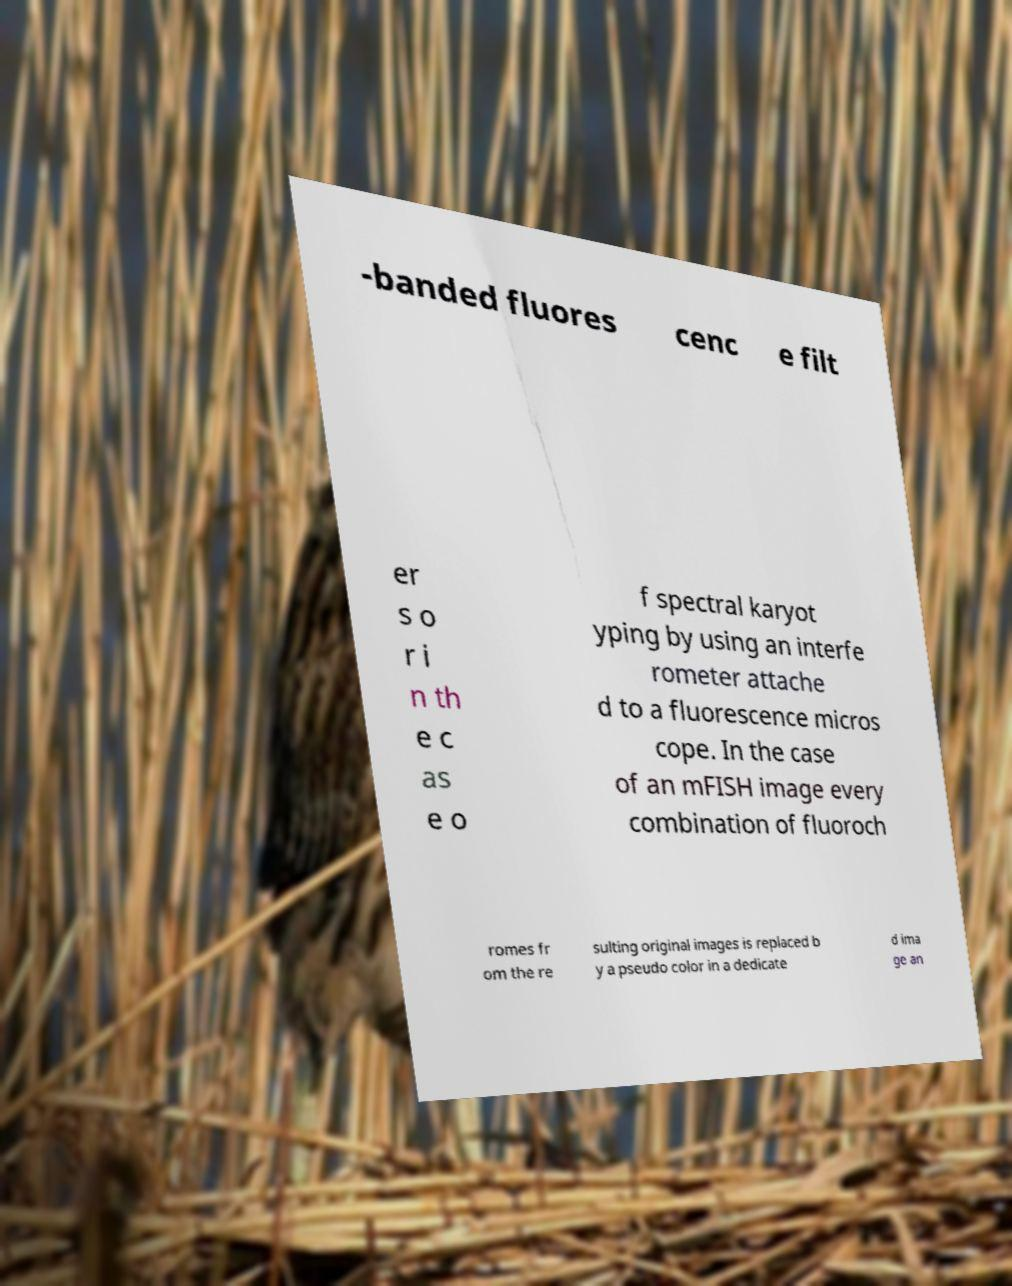Can you accurately transcribe the text from the provided image for me? -banded fluores cenc e filt er s o r i n th e c as e o f spectral karyot yping by using an interfe rometer attache d to a fluorescence micros cope. In the case of an mFISH image every combination of fluoroch romes fr om the re sulting original images is replaced b y a pseudo color in a dedicate d ima ge an 